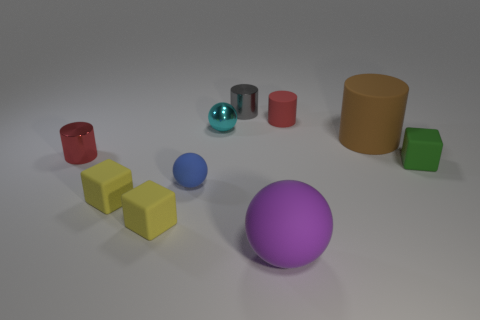There is a matte ball right of the tiny sphere in front of the tiny cyan metal object; how big is it?
Your answer should be very brief. Large. There is another tiny matte object that is the same shape as the brown thing; what is its color?
Provide a succinct answer. Red. How many other cylinders have the same color as the small rubber cylinder?
Give a very brief answer. 1. Is the size of the purple rubber thing the same as the gray metallic object?
Your answer should be compact. No. What is the material of the small blue thing?
Give a very brief answer. Rubber. There is another tiny ball that is the same material as the purple ball; what is its color?
Provide a short and direct response. Blue. Does the big cylinder have the same material as the cylinder in front of the brown object?
Offer a very short reply. No. What number of small yellow objects have the same material as the small green cube?
Provide a succinct answer. 2. There is a tiny metallic object that is on the right side of the tiny cyan metal sphere; what shape is it?
Offer a very short reply. Cylinder. Is the material of the small red cylinder on the right side of the large sphere the same as the red cylinder that is left of the tiny rubber ball?
Ensure brevity in your answer.  No. 